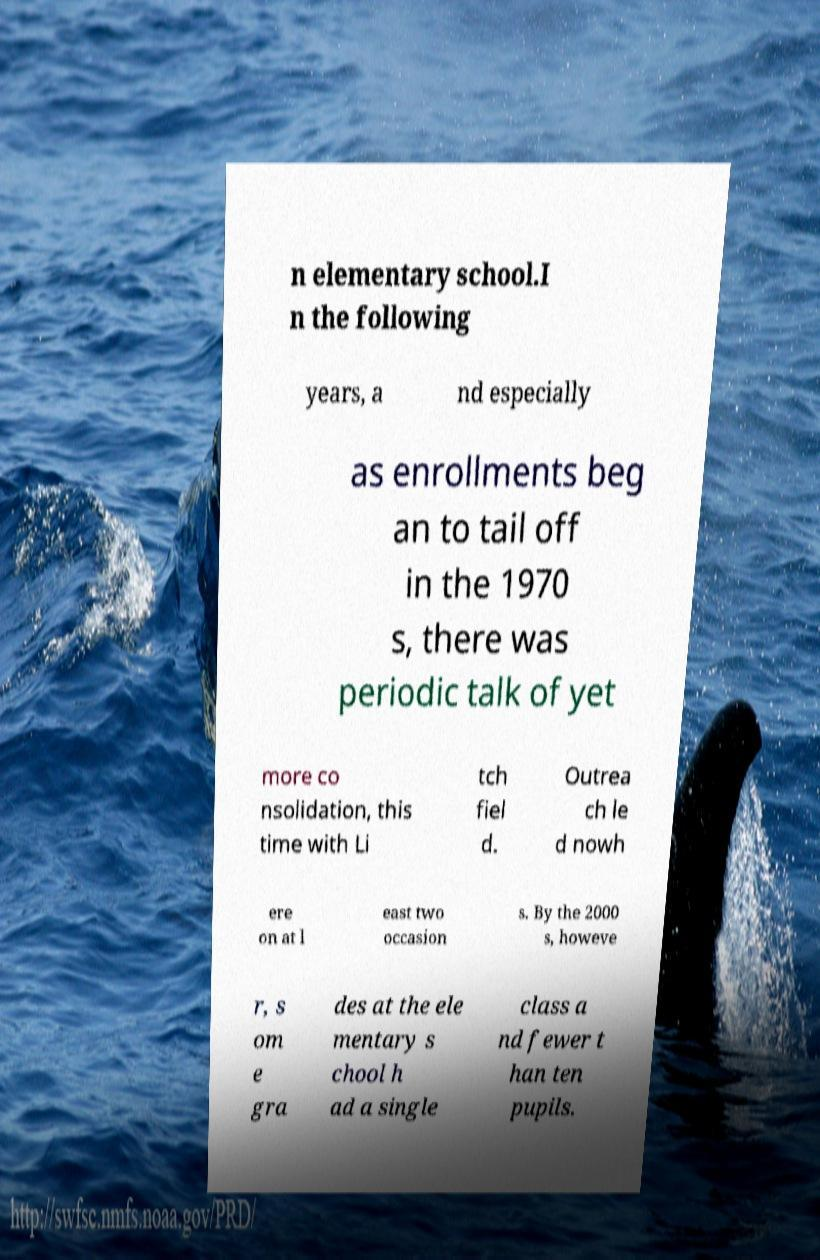Can you accurately transcribe the text from the provided image for me? n elementary school.I n the following years, a nd especially as enrollments beg an to tail off in the 1970 s, there was periodic talk of yet more co nsolidation, this time with Li tch fiel d. Outrea ch le d nowh ere on at l east two occasion s. By the 2000 s, howeve r, s om e gra des at the ele mentary s chool h ad a single class a nd fewer t han ten pupils. 